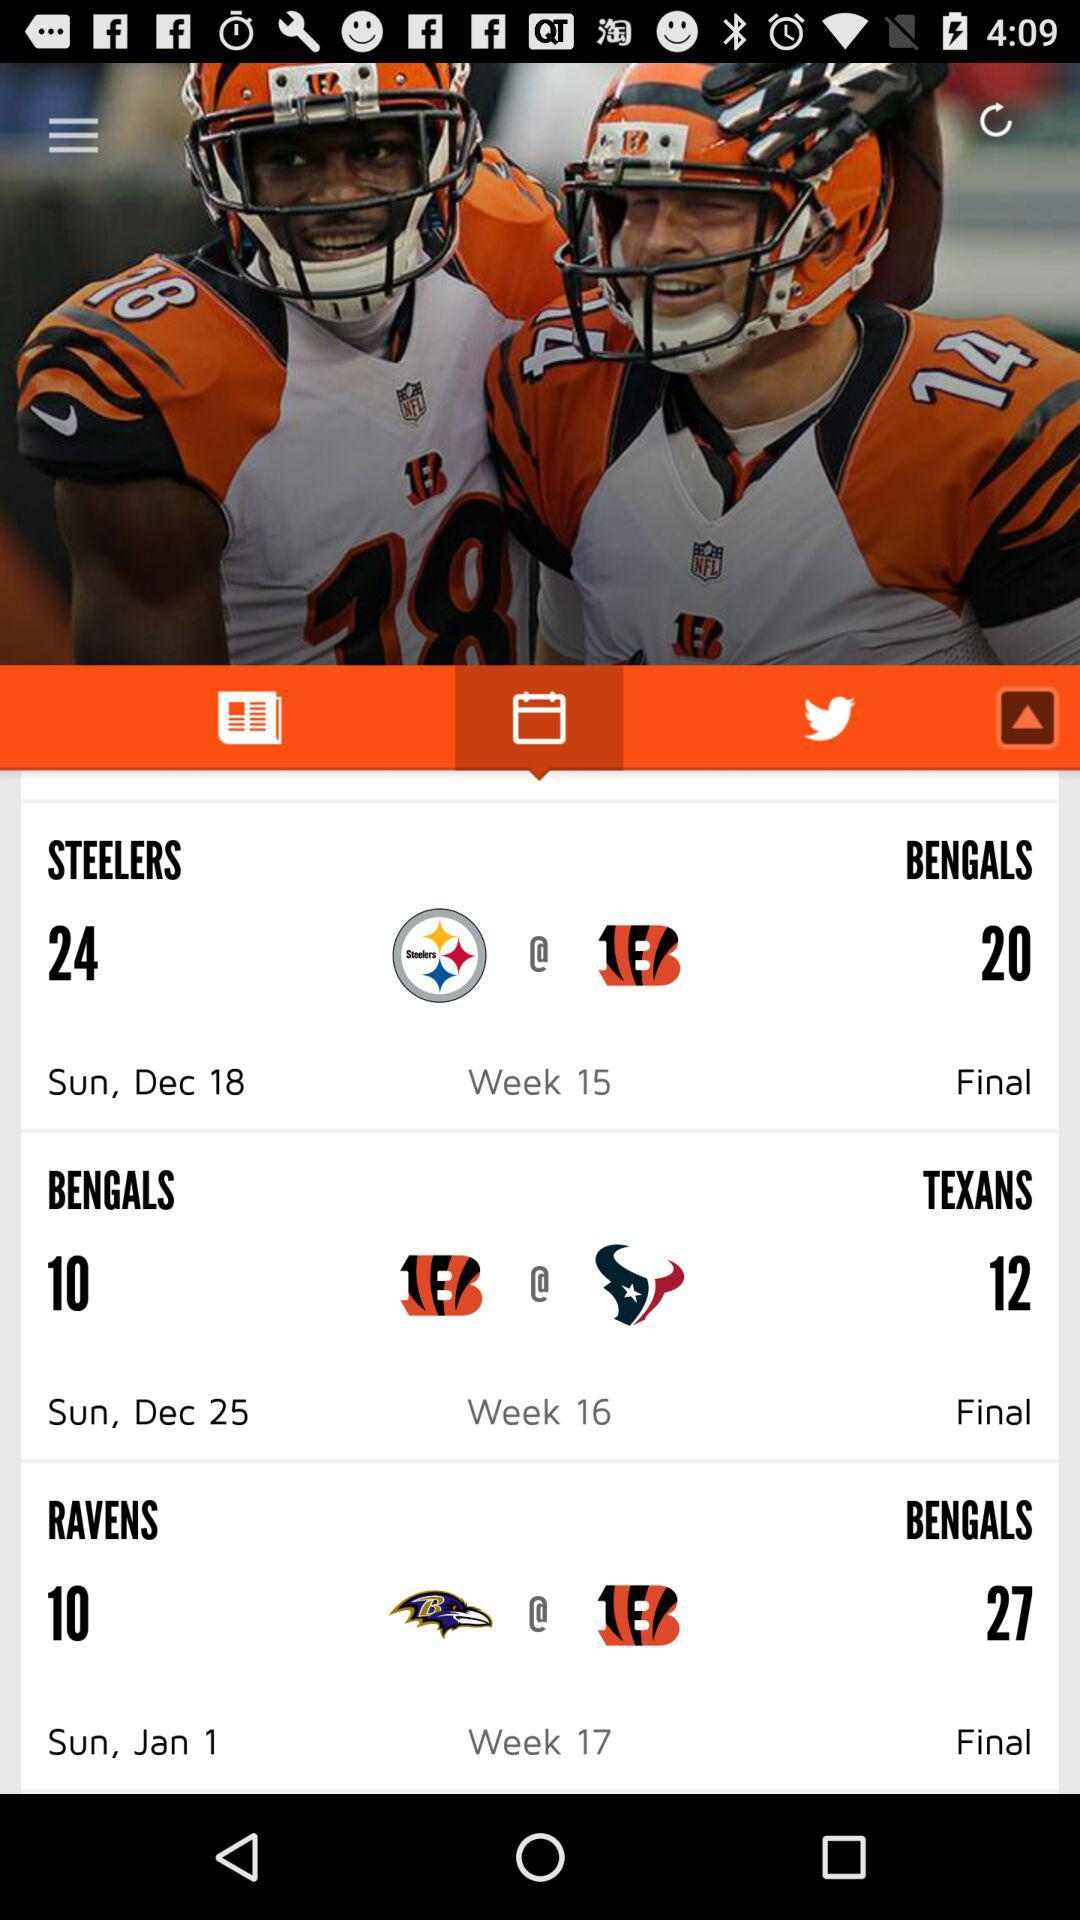How many more points did the Ravens score than the Bengals in their Week 17 game?
Answer the question using a single word or phrase. 17 